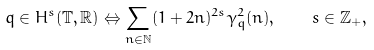<formula> <loc_0><loc_0><loc_500><loc_500>q \in H ^ { s } ( \mathbb { T } , \mathbb { R } ) \Leftrightarrow \sum _ { n \in \mathbb { N } } ( 1 + 2 n ) ^ { 2 s } \gamma _ { q } ^ { 2 } ( n ) , \quad s \in \mathbb { Z } _ { + } ,</formula> 